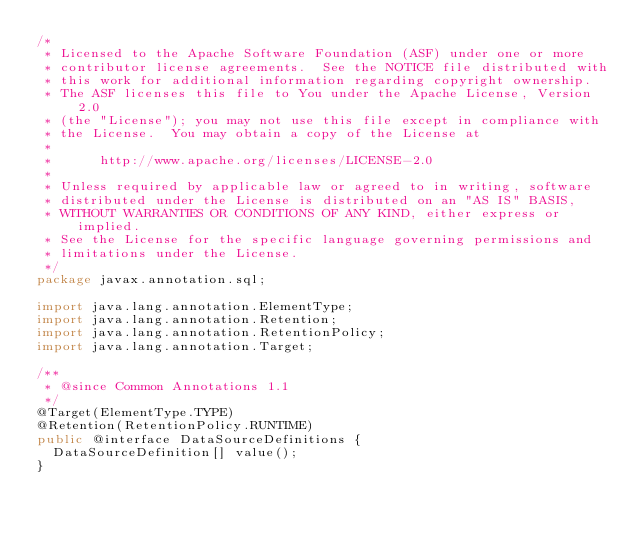<code> <loc_0><loc_0><loc_500><loc_500><_Java_>/*
 * Licensed to the Apache Software Foundation (ASF) under one or more
 * contributor license agreements.  See the NOTICE file distributed with
 * this work for additional information regarding copyright ownership.
 * The ASF licenses this file to You under the Apache License, Version 2.0
 * (the "License"); you may not use this file except in compliance with
 * the License.  You may obtain a copy of the License at
 *
 *      http://www.apache.org/licenses/LICENSE-2.0
 *
 * Unless required by applicable law or agreed to in writing, software
 * distributed under the License is distributed on an "AS IS" BASIS,
 * WITHOUT WARRANTIES OR CONDITIONS OF ANY KIND, either express or implied.
 * See the License for the specific language governing permissions and
 * limitations under the License.
 */
package javax.annotation.sql;

import java.lang.annotation.ElementType;
import java.lang.annotation.Retention;
import java.lang.annotation.RetentionPolicy;
import java.lang.annotation.Target;

/**
 * @since Common Annotations 1.1
 */
@Target(ElementType.TYPE)
@Retention(RetentionPolicy.RUNTIME)
public @interface DataSourceDefinitions {
	DataSourceDefinition[] value();
}
</code> 